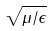<formula> <loc_0><loc_0><loc_500><loc_500>\sqrt { \mu / \epsilon }</formula> 